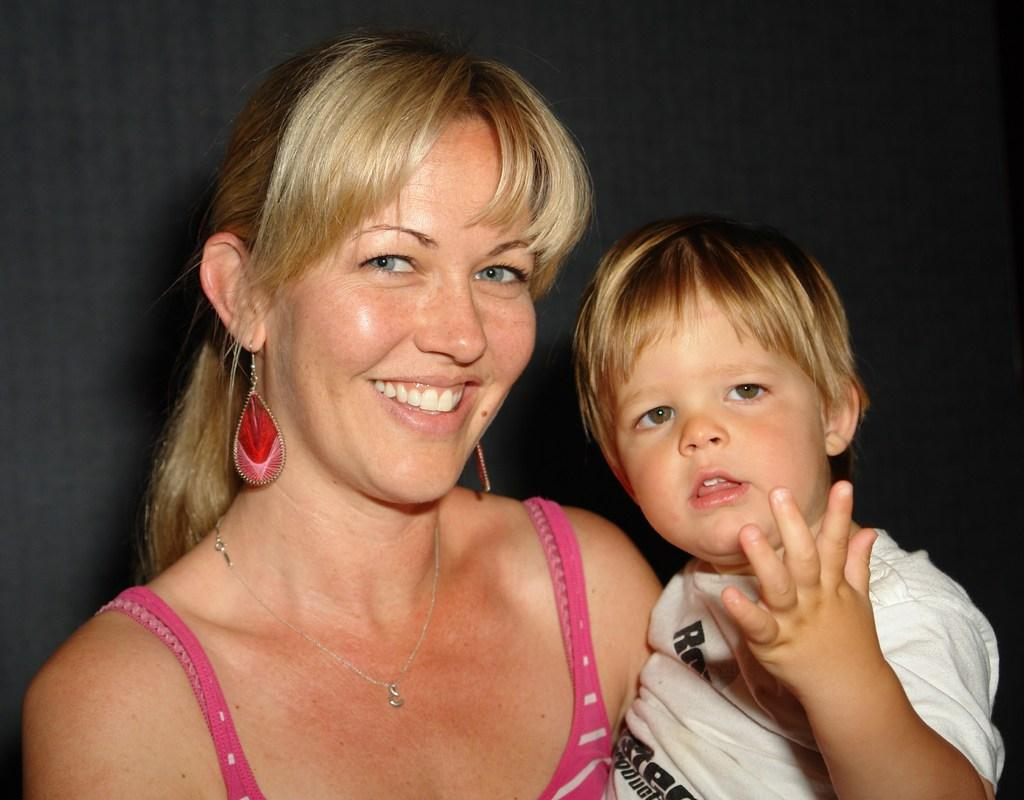Who is present in the image? There is a woman and a kid in the image. What is the woman doing in the image? The woman is smiling in the image. What type of guitar is the woman playing in the image? There is no guitar present in the image; it only features a woman and a kid. 